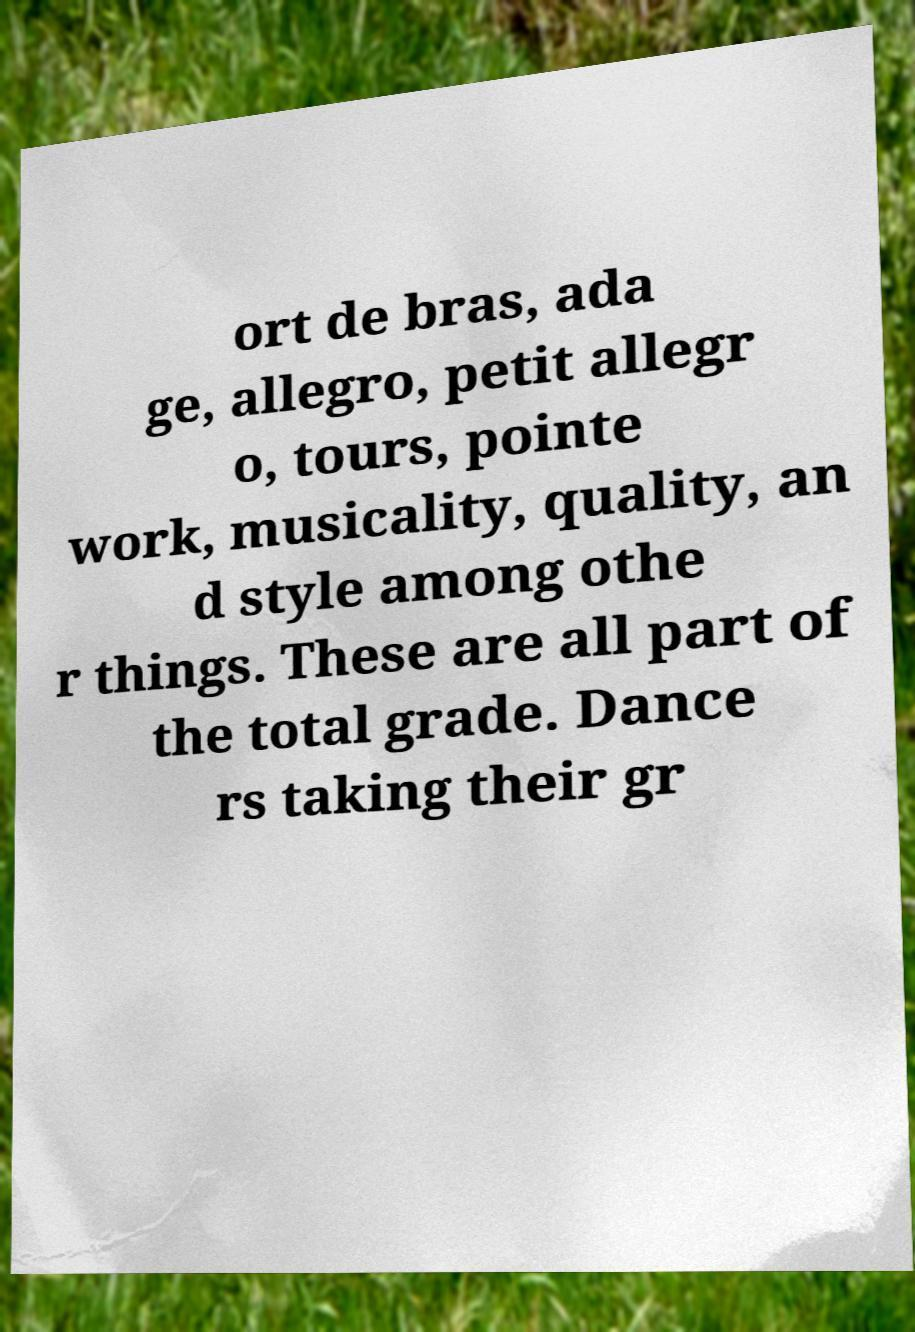Can you read and provide the text displayed in the image?This photo seems to have some interesting text. Can you extract and type it out for me? ort de bras, ada ge, allegro, petit allegr o, tours, pointe work, musicality, quality, an d style among othe r things. These are all part of the total grade. Dance rs taking their gr 